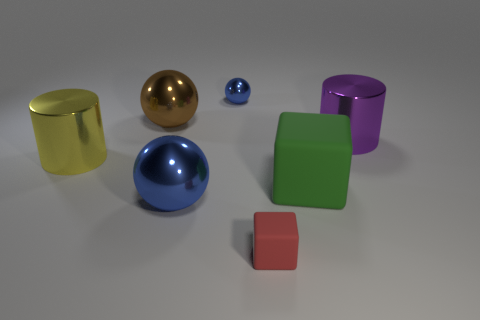How many rubber blocks have the same color as the big matte thing?
Make the answer very short. 0. There is a blue thing that is in front of the shiny cylinder behind the big yellow thing; what is its material?
Provide a succinct answer. Metal. What size is the green matte object?
Keep it short and to the point. Large. What number of brown shiny spheres have the same size as the green block?
Offer a terse response. 1. How many tiny objects are the same shape as the large brown thing?
Offer a terse response. 1. Are there an equal number of blue objects that are to the right of the big matte block and large yellow balls?
Your response must be concise. Yes. The brown object that is the same size as the purple shiny cylinder is what shape?
Your answer should be very brief. Sphere. Is there a big yellow thing of the same shape as the small metal object?
Ensure brevity in your answer.  No. Is there a large object that is to the right of the ball that is behind the large object behind the large purple shiny object?
Offer a very short reply. Yes. Are there more large objects in front of the purple cylinder than red things that are behind the big yellow cylinder?
Keep it short and to the point. Yes. 